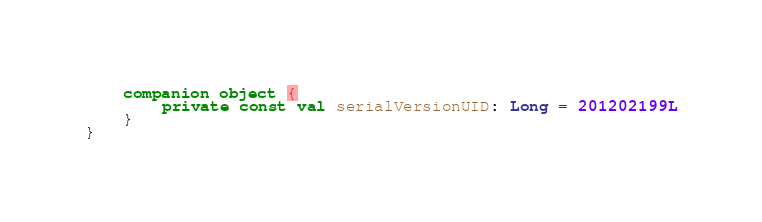<code> <loc_0><loc_0><loc_500><loc_500><_Kotlin_>
    companion object {
        private const val serialVersionUID: Long = 201202199L
    }
}
</code> 